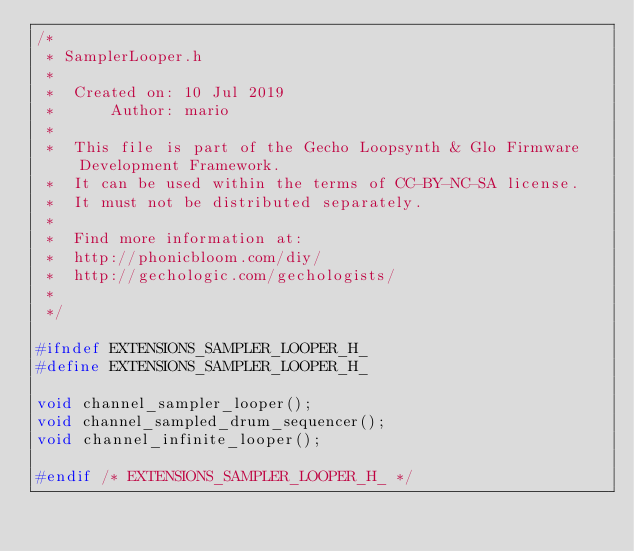Convert code to text. <code><loc_0><loc_0><loc_500><loc_500><_C_>/*
 * SamplerLooper.h
 *
 *  Created on: 10 Jul 2019
 *      Author: mario
 *
 *  This file is part of the Gecho Loopsynth & Glo Firmware Development Framework.
 *  It can be used within the terms of CC-BY-NC-SA license.
 *  It must not be distributed separately.
 *
 *  Find more information at:
 *  http://phonicbloom.com/diy/
 *  http://gechologic.com/gechologists/
 *
 */

#ifndef EXTENSIONS_SAMPLER_LOOPER_H_
#define EXTENSIONS_SAMPLER_LOOPER_H_

void channel_sampler_looper();
void channel_sampled_drum_sequencer();
void channel_infinite_looper();

#endif /* EXTENSIONS_SAMPLER_LOOPER_H_ */
</code> 